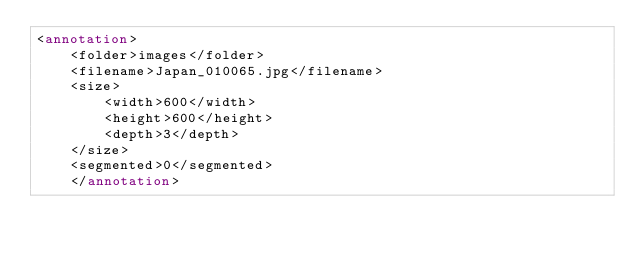<code> <loc_0><loc_0><loc_500><loc_500><_XML_><annotation>
    <folder>images</folder>
    <filename>Japan_010065.jpg</filename>
    <size>
        <width>600</width>
        <height>600</height>
        <depth>3</depth>
    </size>
    <segmented>0</segmented>
    </annotation></code> 